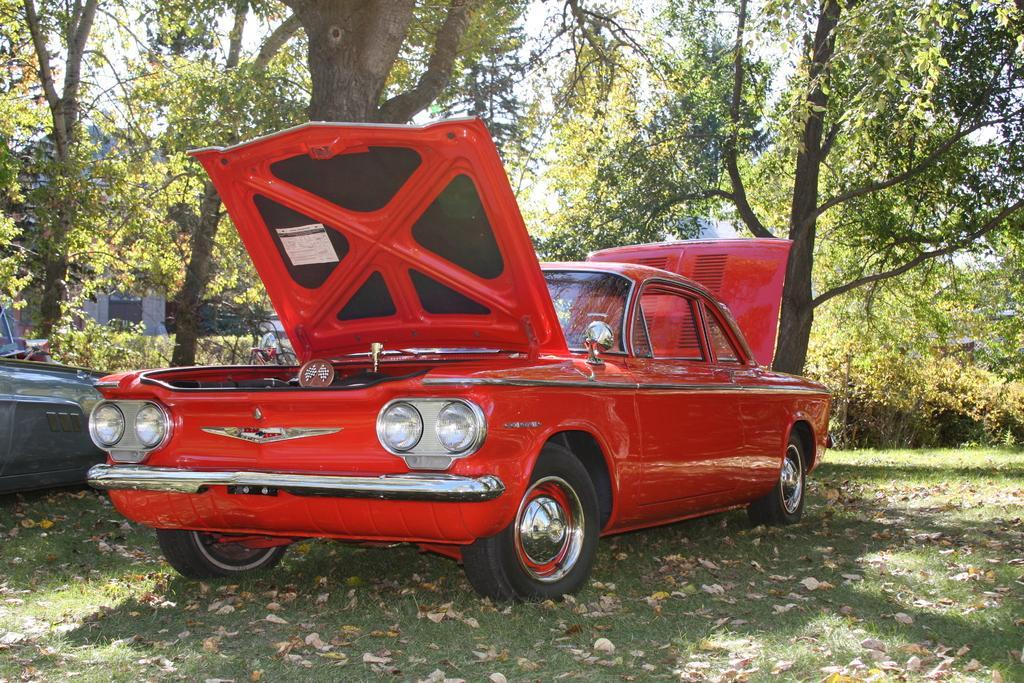Please provide a concise description of this image. In this image I can see a red color car visible under the tree and back side of tree it might be the tree it might be the sky and the house and there is a vehicle part visible on the left side 